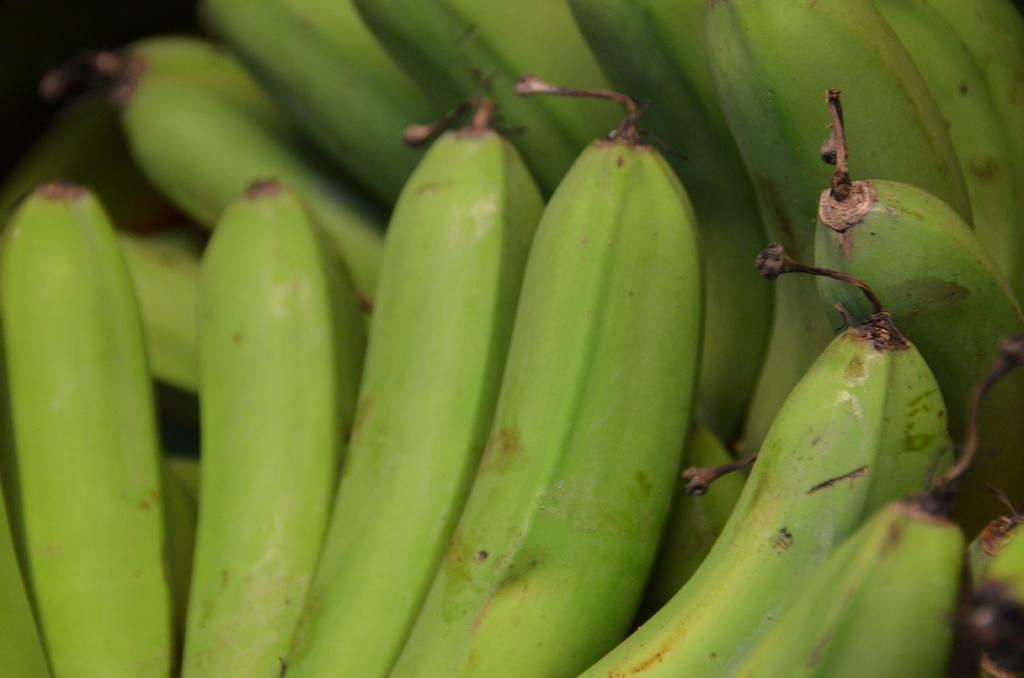What type of fruit is visible in the image? There are bunches of green bananas in the image. Can you see a rabbit sneezing in the image? There is no rabbit or sneezing present in the image; it only features bunches of green bananas. 